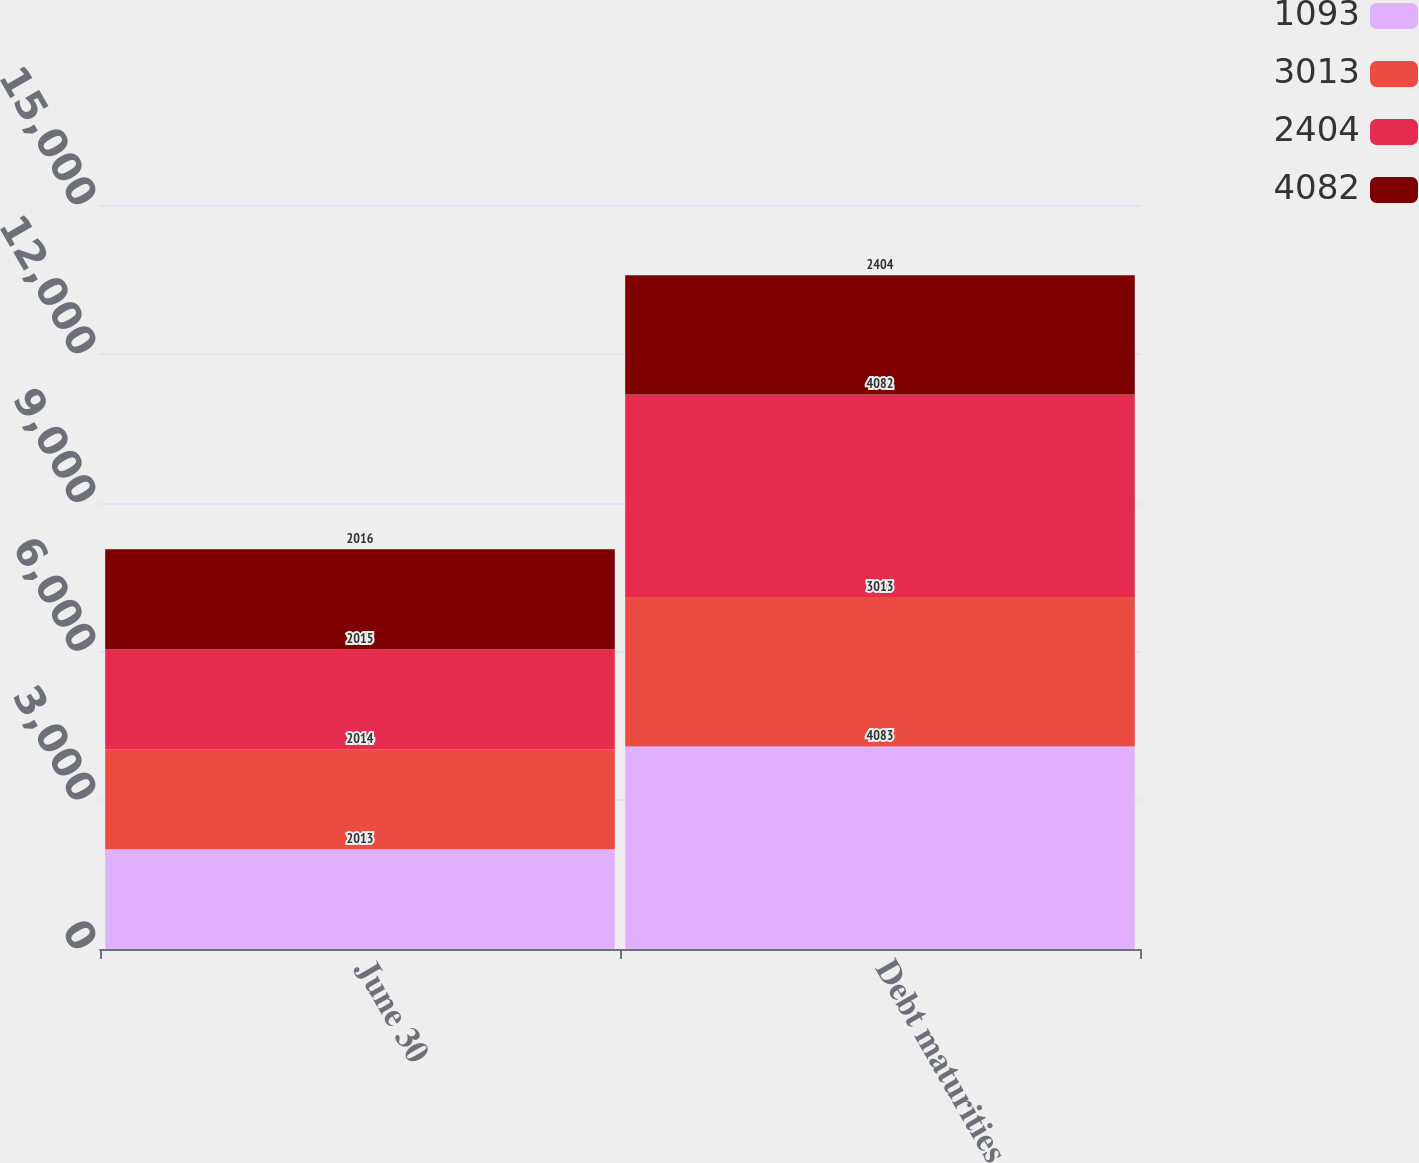Convert chart. <chart><loc_0><loc_0><loc_500><loc_500><stacked_bar_chart><ecel><fcel>June 30<fcel>Debt maturities<nl><fcel>1093<fcel>2013<fcel>4083<nl><fcel>3013<fcel>2014<fcel>3013<nl><fcel>2404<fcel>2015<fcel>4082<nl><fcel>4082<fcel>2016<fcel>2404<nl></chart> 